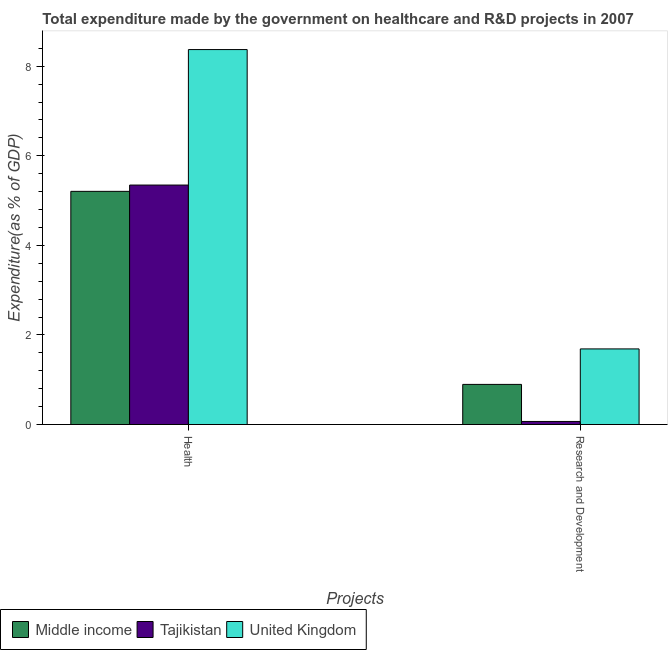How many groups of bars are there?
Make the answer very short. 2. How many bars are there on the 2nd tick from the left?
Your answer should be compact. 3. What is the label of the 1st group of bars from the left?
Provide a succinct answer. Health. What is the expenditure in r&d in Middle income?
Your response must be concise. 0.9. Across all countries, what is the maximum expenditure in healthcare?
Your answer should be compact. 8.37. Across all countries, what is the minimum expenditure in r&d?
Give a very brief answer. 0.07. In which country was the expenditure in r&d maximum?
Your response must be concise. United Kingdom. In which country was the expenditure in r&d minimum?
Ensure brevity in your answer.  Tajikistan. What is the total expenditure in r&d in the graph?
Your answer should be very brief. 2.65. What is the difference between the expenditure in r&d in Tajikistan and that in Middle income?
Ensure brevity in your answer.  -0.83. What is the difference between the expenditure in healthcare in United Kingdom and the expenditure in r&d in Middle income?
Provide a succinct answer. 7.48. What is the average expenditure in healthcare per country?
Provide a short and direct response. 6.31. What is the difference between the expenditure in healthcare and expenditure in r&d in Middle income?
Offer a very short reply. 4.31. What is the ratio of the expenditure in r&d in Middle income to that in Tajikistan?
Give a very brief answer. 13.21. Is the expenditure in healthcare in Middle income less than that in Tajikistan?
Provide a short and direct response. Yes. What does the 2nd bar from the left in Research and Development represents?
Your response must be concise. Tajikistan. How many countries are there in the graph?
Offer a terse response. 3. Does the graph contain any zero values?
Your answer should be compact. No. Does the graph contain grids?
Provide a short and direct response. No. Where does the legend appear in the graph?
Your answer should be very brief. Bottom left. What is the title of the graph?
Give a very brief answer. Total expenditure made by the government on healthcare and R&D projects in 2007. Does "Zimbabwe" appear as one of the legend labels in the graph?
Keep it short and to the point. No. What is the label or title of the X-axis?
Keep it short and to the point. Projects. What is the label or title of the Y-axis?
Offer a very short reply. Expenditure(as % of GDP). What is the Expenditure(as % of GDP) of Middle income in Health?
Offer a very short reply. 5.21. What is the Expenditure(as % of GDP) of Tajikistan in Health?
Make the answer very short. 5.35. What is the Expenditure(as % of GDP) in United Kingdom in Health?
Make the answer very short. 8.37. What is the Expenditure(as % of GDP) in Middle income in Research and Development?
Provide a short and direct response. 0.9. What is the Expenditure(as % of GDP) in Tajikistan in Research and Development?
Keep it short and to the point. 0.07. What is the Expenditure(as % of GDP) of United Kingdom in Research and Development?
Keep it short and to the point. 1.69. Across all Projects, what is the maximum Expenditure(as % of GDP) in Middle income?
Keep it short and to the point. 5.21. Across all Projects, what is the maximum Expenditure(as % of GDP) in Tajikistan?
Your answer should be compact. 5.35. Across all Projects, what is the maximum Expenditure(as % of GDP) of United Kingdom?
Your answer should be very brief. 8.37. Across all Projects, what is the minimum Expenditure(as % of GDP) of Middle income?
Provide a succinct answer. 0.9. Across all Projects, what is the minimum Expenditure(as % of GDP) of Tajikistan?
Your answer should be very brief. 0.07. Across all Projects, what is the minimum Expenditure(as % of GDP) in United Kingdom?
Give a very brief answer. 1.69. What is the total Expenditure(as % of GDP) of Middle income in the graph?
Give a very brief answer. 6.1. What is the total Expenditure(as % of GDP) of Tajikistan in the graph?
Provide a succinct answer. 5.41. What is the total Expenditure(as % of GDP) in United Kingdom in the graph?
Give a very brief answer. 10.06. What is the difference between the Expenditure(as % of GDP) of Middle income in Health and that in Research and Development?
Provide a succinct answer. 4.31. What is the difference between the Expenditure(as % of GDP) in Tajikistan in Health and that in Research and Development?
Offer a terse response. 5.28. What is the difference between the Expenditure(as % of GDP) of United Kingdom in Health and that in Research and Development?
Provide a succinct answer. 6.68. What is the difference between the Expenditure(as % of GDP) of Middle income in Health and the Expenditure(as % of GDP) of Tajikistan in Research and Development?
Your answer should be compact. 5.14. What is the difference between the Expenditure(as % of GDP) of Middle income in Health and the Expenditure(as % of GDP) of United Kingdom in Research and Development?
Give a very brief answer. 3.52. What is the difference between the Expenditure(as % of GDP) in Tajikistan in Health and the Expenditure(as % of GDP) in United Kingdom in Research and Development?
Provide a short and direct response. 3.66. What is the average Expenditure(as % of GDP) in Middle income per Projects?
Your answer should be compact. 3.05. What is the average Expenditure(as % of GDP) in Tajikistan per Projects?
Provide a short and direct response. 2.71. What is the average Expenditure(as % of GDP) in United Kingdom per Projects?
Provide a short and direct response. 5.03. What is the difference between the Expenditure(as % of GDP) in Middle income and Expenditure(as % of GDP) in Tajikistan in Health?
Provide a succinct answer. -0.14. What is the difference between the Expenditure(as % of GDP) of Middle income and Expenditure(as % of GDP) of United Kingdom in Health?
Give a very brief answer. -3.17. What is the difference between the Expenditure(as % of GDP) of Tajikistan and Expenditure(as % of GDP) of United Kingdom in Health?
Make the answer very short. -3.02. What is the difference between the Expenditure(as % of GDP) of Middle income and Expenditure(as % of GDP) of Tajikistan in Research and Development?
Give a very brief answer. 0.83. What is the difference between the Expenditure(as % of GDP) in Middle income and Expenditure(as % of GDP) in United Kingdom in Research and Development?
Your answer should be very brief. -0.79. What is the difference between the Expenditure(as % of GDP) in Tajikistan and Expenditure(as % of GDP) in United Kingdom in Research and Development?
Offer a very short reply. -1.62. What is the ratio of the Expenditure(as % of GDP) of Middle income in Health to that in Research and Development?
Keep it short and to the point. 5.81. What is the ratio of the Expenditure(as % of GDP) in Tajikistan in Health to that in Research and Development?
Your response must be concise. 78.88. What is the ratio of the Expenditure(as % of GDP) of United Kingdom in Health to that in Research and Development?
Provide a succinct answer. 4.96. What is the difference between the highest and the second highest Expenditure(as % of GDP) of Middle income?
Keep it short and to the point. 4.31. What is the difference between the highest and the second highest Expenditure(as % of GDP) of Tajikistan?
Your answer should be compact. 5.28. What is the difference between the highest and the second highest Expenditure(as % of GDP) of United Kingdom?
Give a very brief answer. 6.68. What is the difference between the highest and the lowest Expenditure(as % of GDP) of Middle income?
Your answer should be compact. 4.31. What is the difference between the highest and the lowest Expenditure(as % of GDP) in Tajikistan?
Make the answer very short. 5.28. What is the difference between the highest and the lowest Expenditure(as % of GDP) in United Kingdom?
Your answer should be compact. 6.68. 